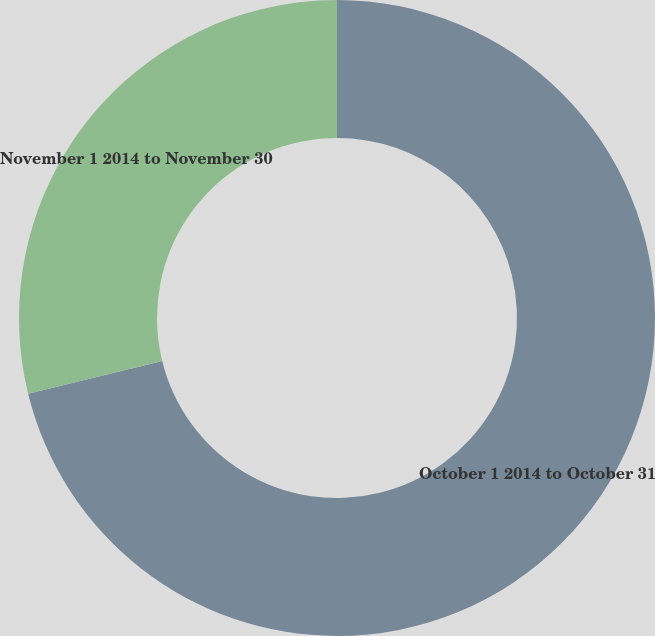Convert chart. <chart><loc_0><loc_0><loc_500><loc_500><pie_chart><fcel>October 1 2014 to October 31<fcel>November 1 2014 to November 30<nl><fcel>71.17%<fcel>28.83%<nl></chart> 